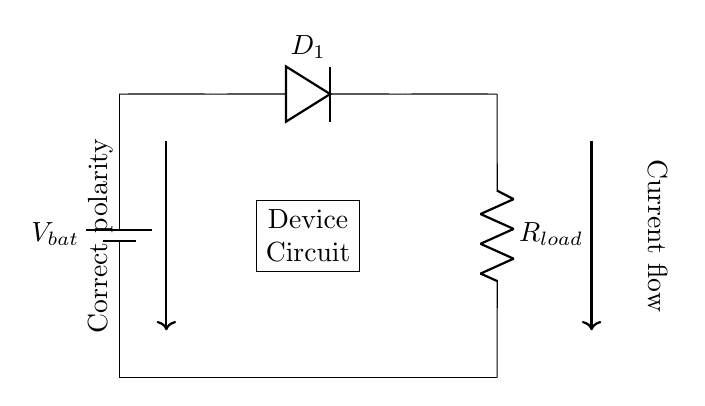What is the component used for reverse polarity protection? The component used for reverse polarity protection in this circuit is a diode, specifically labeled as D1 in the diagram. Diodes only allow current to flow in one direction, preventing damage from incorrect polarity.
Answer: diode What is the purpose of the battery in this circuit? The battery provides the necessary voltage to power the device. In the circuit, it is represented as Vbat, which is the source of electrical energy for the load and associated components.
Answer: voltage source What happens if the battery is connected in reverse? If the battery is connected in reverse, the diode D1 will be reverse-biased. This means no current will flow through the load, protecting it from reverse voltage damage.
Answer: no current flow What type of load is shown in the circuit? The circuit shows a resistive load, labeled as Rload. This indicates a general device load that consumes power in the form of resistance.
Answer: resistive load How does the current flow in the correct polarity? The current flows from the positive terminal of the battery, through the diode D1 (which is forward-biased), and then through the resistor Rload, completing the circuit.
Answer: through the diode D1 What indicates the direction of current flow in the circuit? The current flow is indicated by the arrows shown near the connections in the circuit diagram. They demonstrate the intended flow of current from the positive battery terminal through the diode to the load.
Answer: arrows What would happen to the load if the diode was not present in the circuit? Without the diode, if the battery were connected in reverse, the load would likely receive a reverse voltage that could damage or destroy it. The diode protects the load from this scenario.
Answer: damage or destruction 